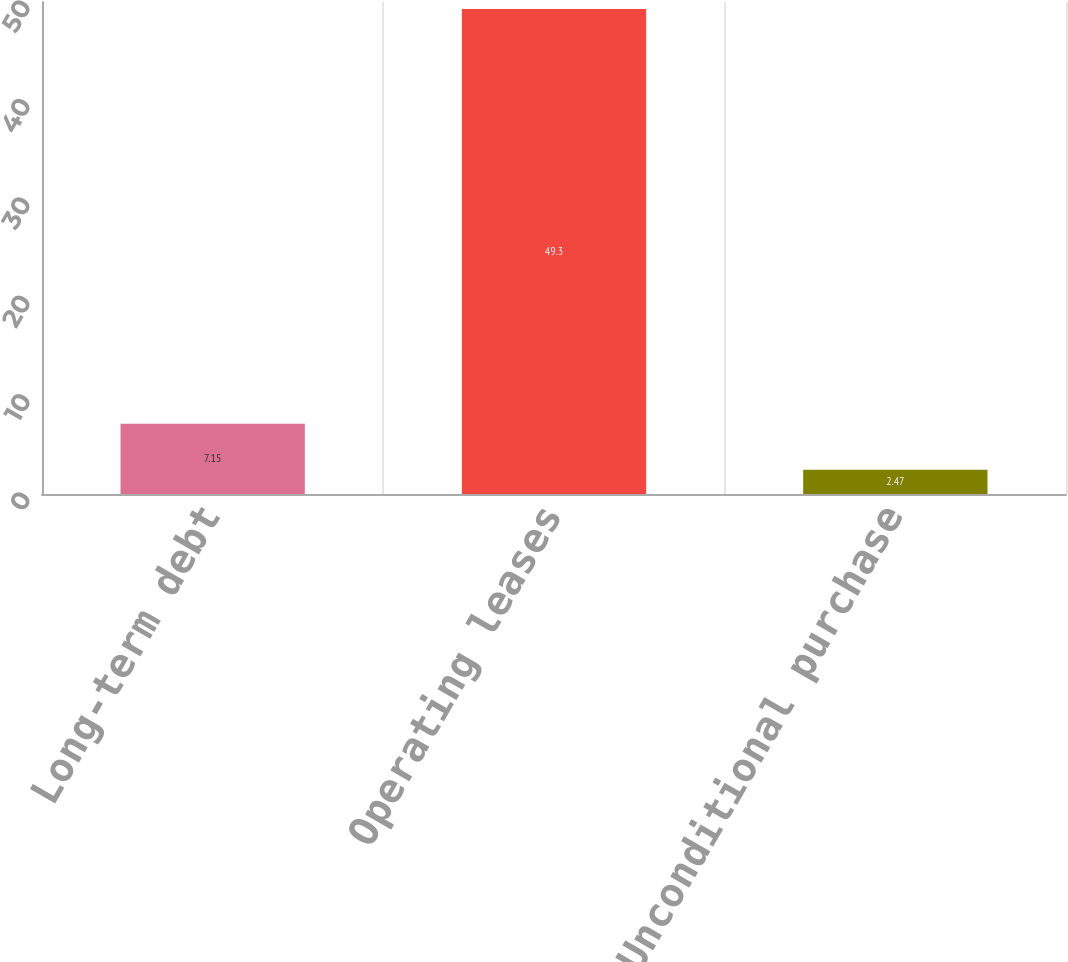Convert chart to OTSL. <chart><loc_0><loc_0><loc_500><loc_500><bar_chart><fcel>Long-term debt<fcel>Operating leases<fcel>Unconditional purchase<nl><fcel>7.15<fcel>49.3<fcel>2.47<nl></chart> 